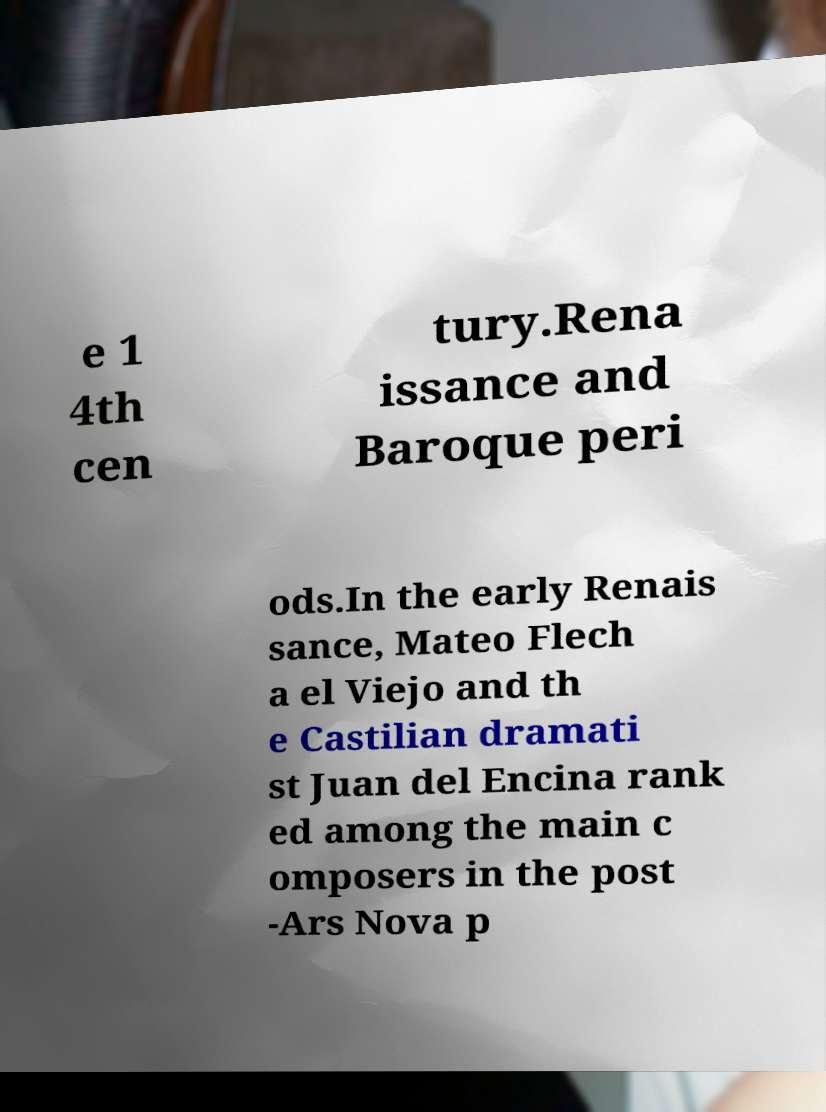Could you extract and type out the text from this image? e 1 4th cen tury.Rena issance and Baroque peri ods.In the early Renais sance, Mateo Flech a el Viejo and th e Castilian dramati st Juan del Encina rank ed among the main c omposers in the post -Ars Nova p 